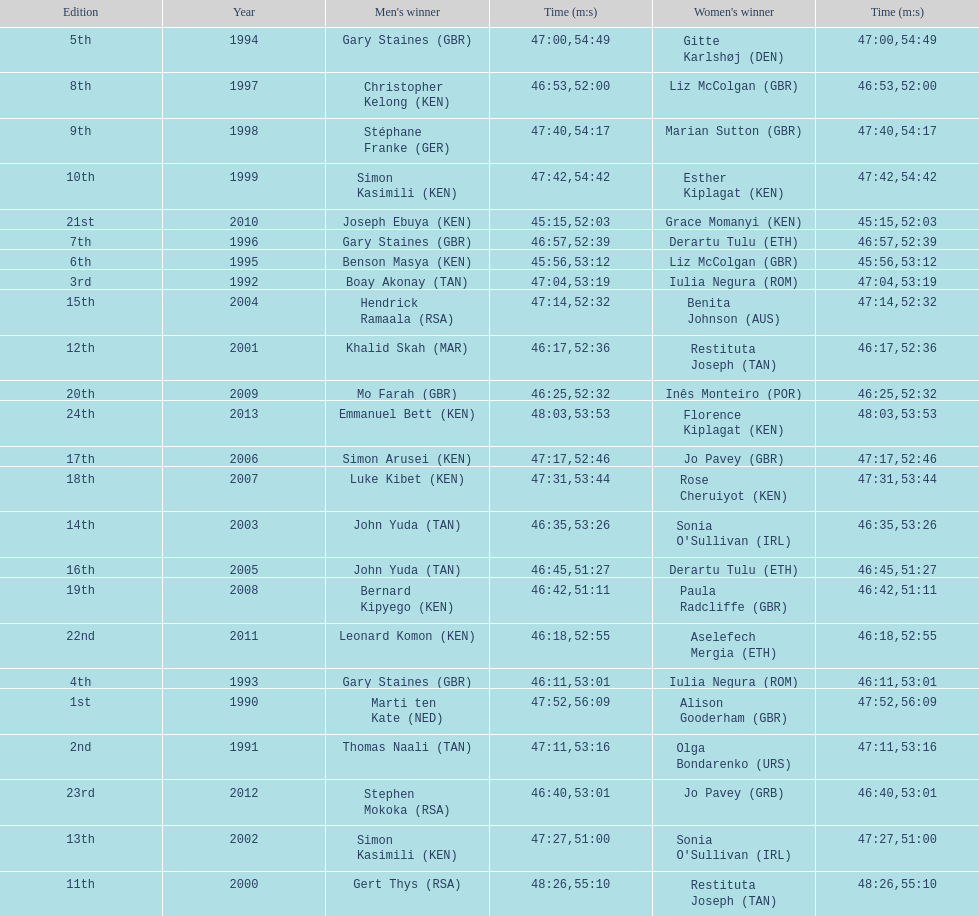Who has the fastest recorded finish for the men's bupa great south run, between 1990 and 2013? Joseph Ebuya (KEN). 